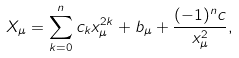Convert formula to latex. <formula><loc_0><loc_0><loc_500><loc_500>X _ { \mu } = \sum _ { k = 0 } ^ { n } c _ { k } x _ { \mu } ^ { 2 k } + b _ { \mu } + \frac { ( - 1 ) ^ { n } c } { x _ { \mu } ^ { 2 } } ,</formula> 